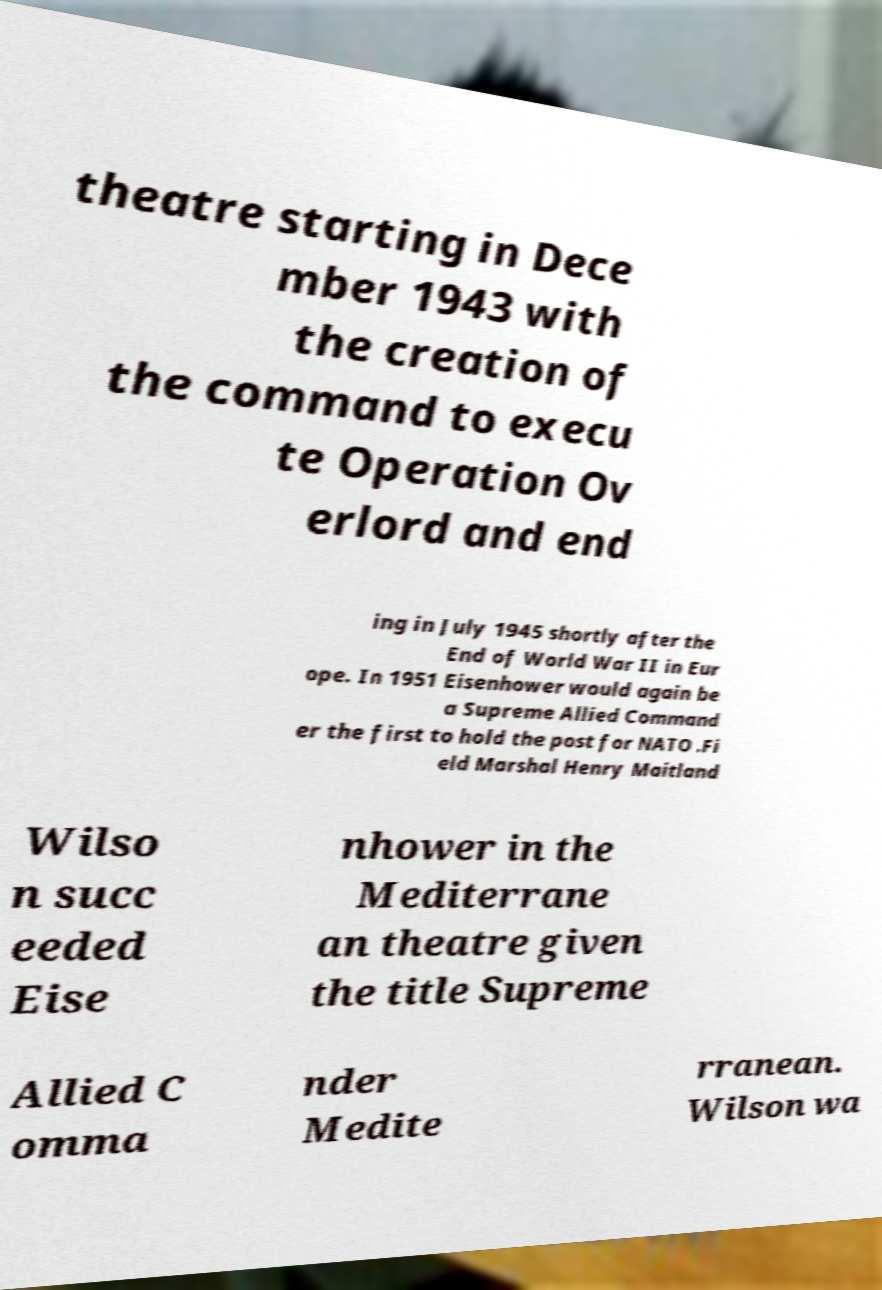Please identify and transcribe the text found in this image. theatre starting in Dece mber 1943 with the creation of the command to execu te Operation Ov erlord and end ing in July 1945 shortly after the End of World War II in Eur ope. In 1951 Eisenhower would again be a Supreme Allied Command er the first to hold the post for NATO .Fi eld Marshal Henry Maitland Wilso n succ eeded Eise nhower in the Mediterrane an theatre given the title Supreme Allied C omma nder Medite rranean. Wilson wa 